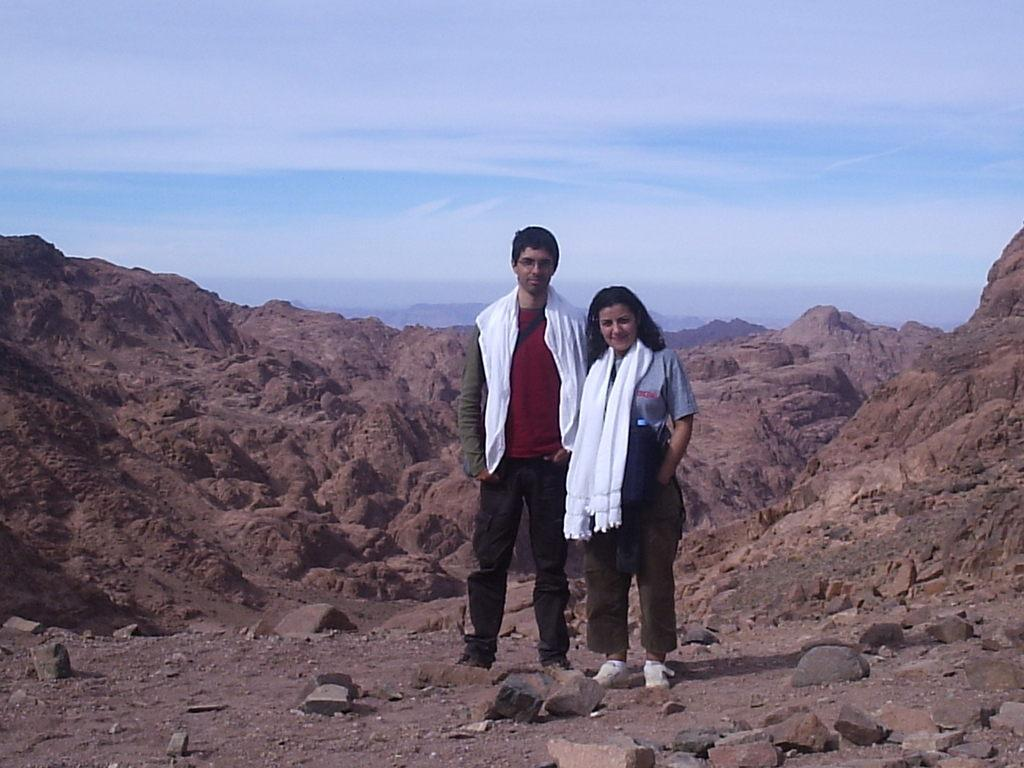How many people are in the image? There are two people in the image, a man and a woman. What are the positions of the man and the woman in the image? Both the man and the woman are standing. What can be seen around the man and the woman in the image? Rocks are present around them. What is visible in the background of the image? Hills and clouds are visible in the background of the image. How many fish can be seen swimming in the water in the image? There is no water or fish present in the image; it features a man and a woman standing near rocks with hills and clouds in the background. 